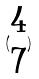Convert formula to latex. <formula><loc_0><loc_0><loc_500><loc_500>( \begin{matrix} 4 \\ 7 \end{matrix} )</formula> 